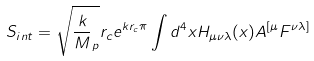<formula> <loc_0><loc_0><loc_500><loc_500>S _ { i n t } = \sqrt { \frac { k } { M } _ { p } } r _ { c } e ^ { k r _ { c } \pi } \int d ^ { 4 } x H _ { \mu \nu \lambda } ( x ) A ^ { [ \mu } F ^ { \nu \lambda ] }</formula> 